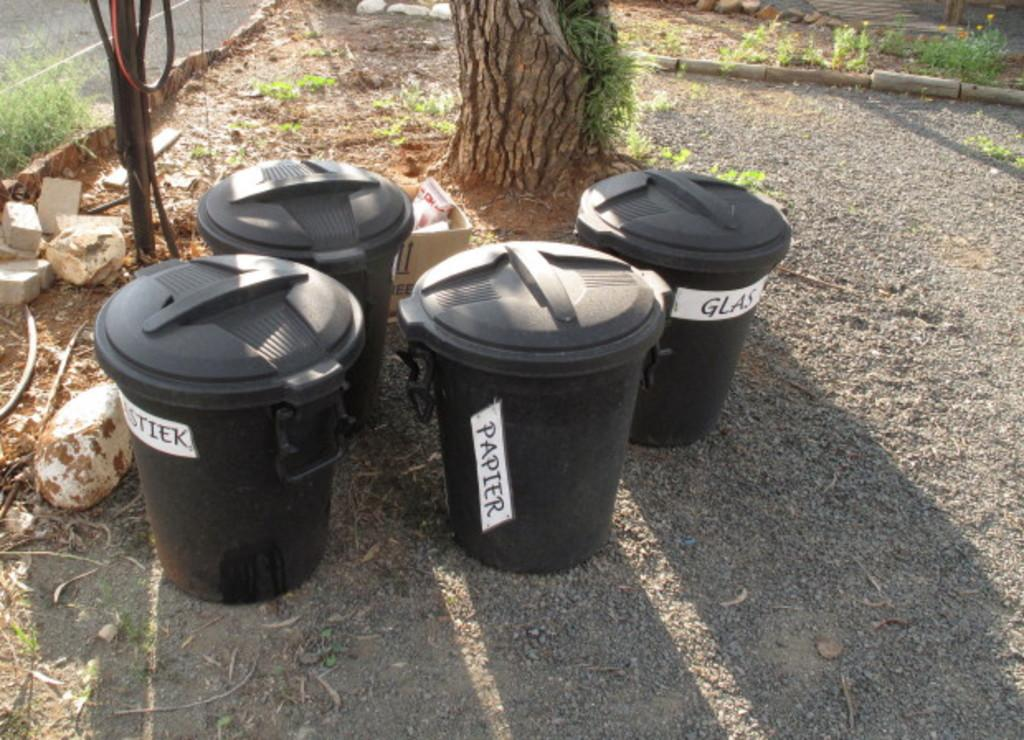<image>
Give a short and clear explanation of the subsequent image. A set of trash bins are labeled for paper, glass, and other types of trash. 